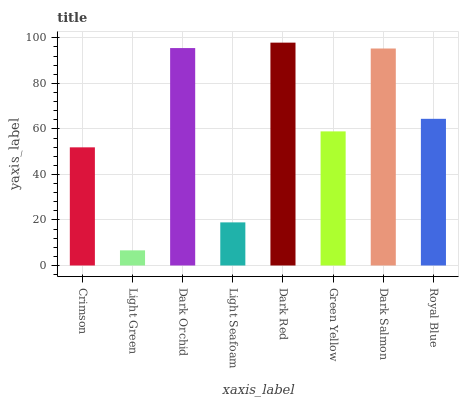Is Light Green the minimum?
Answer yes or no. Yes. Is Dark Red the maximum?
Answer yes or no. Yes. Is Dark Orchid the minimum?
Answer yes or no. No. Is Dark Orchid the maximum?
Answer yes or no. No. Is Dark Orchid greater than Light Green?
Answer yes or no. Yes. Is Light Green less than Dark Orchid?
Answer yes or no. Yes. Is Light Green greater than Dark Orchid?
Answer yes or no. No. Is Dark Orchid less than Light Green?
Answer yes or no. No. Is Royal Blue the high median?
Answer yes or no. Yes. Is Green Yellow the low median?
Answer yes or no. Yes. Is Light Seafoam the high median?
Answer yes or no. No. Is Dark Salmon the low median?
Answer yes or no. No. 